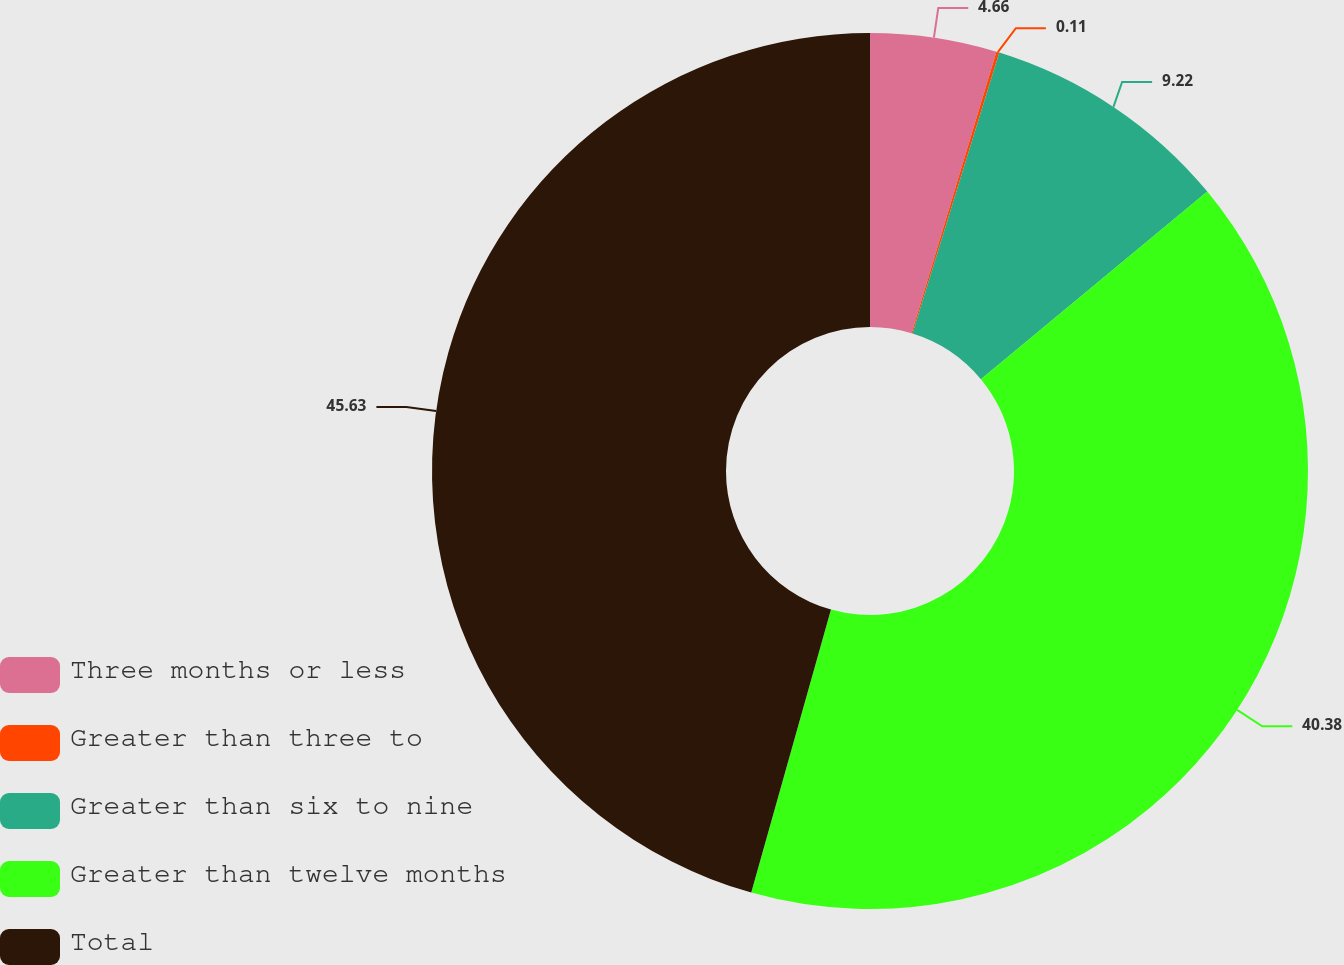<chart> <loc_0><loc_0><loc_500><loc_500><pie_chart><fcel>Three months or less<fcel>Greater than three to<fcel>Greater than six to nine<fcel>Greater than twelve months<fcel>Total<nl><fcel>4.66%<fcel>0.11%<fcel>9.22%<fcel>40.38%<fcel>45.63%<nl></chart> 